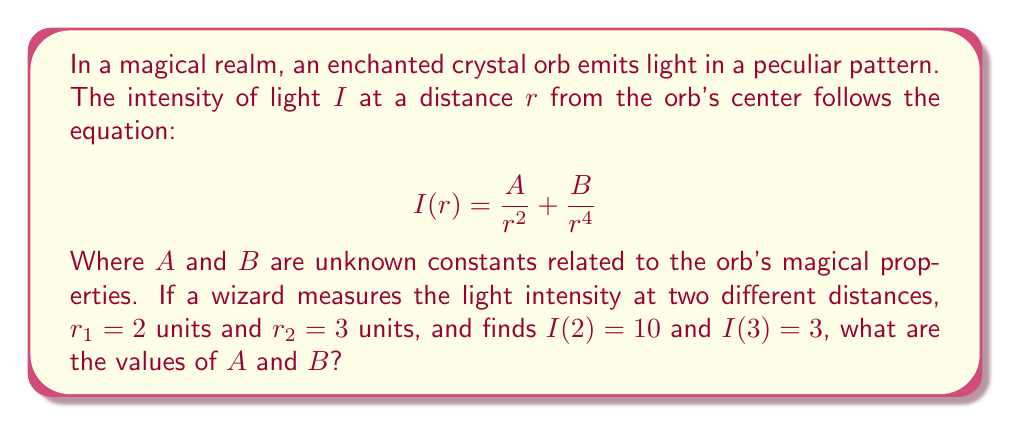Give your solution to this math problem. To solve this enchanted problem, we'll follow these mystical steps:

1) We have two equations based on the given information:
   $$10 = \frac{A}{2^2} + \frac{B}{2^4}$$
   $$3 = \frac{A}{3^2} + \frac{B}{3^4}$$

2) Simplify the first equation:
   $$10 = \frac{A}{4} + \frac{B}{16}$$

3) Simplify the second equation:
   $$3 = \frac{A}{9} + \frac{B}{81}$$

4) Multiply the first equation by 9 and the second by 4:
   $$90 = \frac{9A}{4} + \frac{9B}{16}$$
   $$12 = \frac{4A}{9} + \frac{4B}{81}$$

5) Subtract the second equation from the first:
   $$78 = \frac{81A}{36} + \frac{81B}{144} - \frac{16A}{36} - \frac{16B}{324}$$

6) Simplify:
   $$78 = \frac{65A}{36} + \frac{405B}{324} - \frac{16B}{324}$$
   $$78 = \frac{65A}{36} + \frac{389B}{324}$$

7) Multiply both sides by 324:
   $$25,272 = 585A + 389B$$

8) This is our first equation. Now, let's go back to the original equations and multiply the first by 81 and the second by 16:
   $$810 = \frac{81A}{4} + \frac{81B}{16}$$
   $$48 = \frac{16A}{9} + \frac{16B}{81}$$

9) Subtract the second equation from the first:
   $$762 = \frac{729A}{36} + \frac{729B}{144} - \frac{64A}{36} - \frac{64B}{324}$$

10) Simplify:
    $$762 = \frac{665A}{36} + \frac{3645B}{324} - \frac{64B}{324}$$
    $$762 = \frac{665A}{36} + \frac{3581B}{324}$$

11) Multiply both sides by 324:
    $$246,888 = 5,985A + 3,581B$$

12) Now we have a system of two equations:
    $$25,272 = 585A + 389B$$
    $$246,888 = 5,985A + 3,581B$$

13) Multiply the first equation by 10 and subtract from the second:
    $$246,888 - 252,720 = 5,985A + 3,581B - 5,850A - 3,890B$$
    $$-5,832 = 135A - 309B$$

14) Divide by 3:
    $$-1,944 = 45A - 103B$$

15) This is our new first equation. Our second equation is still:
    $$25,272 = 585A + 389B$$

16) Multiply the first equation by 13 and the second by 1:
    $$-25,272 = 585A - 1,339B$$
    $$25,272 = 585A + 389B$$

17) Add these equations:
    $$0 = 1,170A - 950B$$
    $$B = \frac{117A}{95}$$

18) Substitute this into our original equation:
    $$25,272 = 585A + 389(\frac{117A}{95})$$
    $$25,272 = 585A + \frac{45,513A}{95}$$
    $$2,400,840 = 55,575A + 45,513A$$
    $$2,400,840 = 101,088A$$
    $$A = 23.75$$

19) Now we can find B:
    $$B = \frac{117(23.75)}{95} = 29.25$$
Answer: $A = 23.75$, $B = 29.25$ 